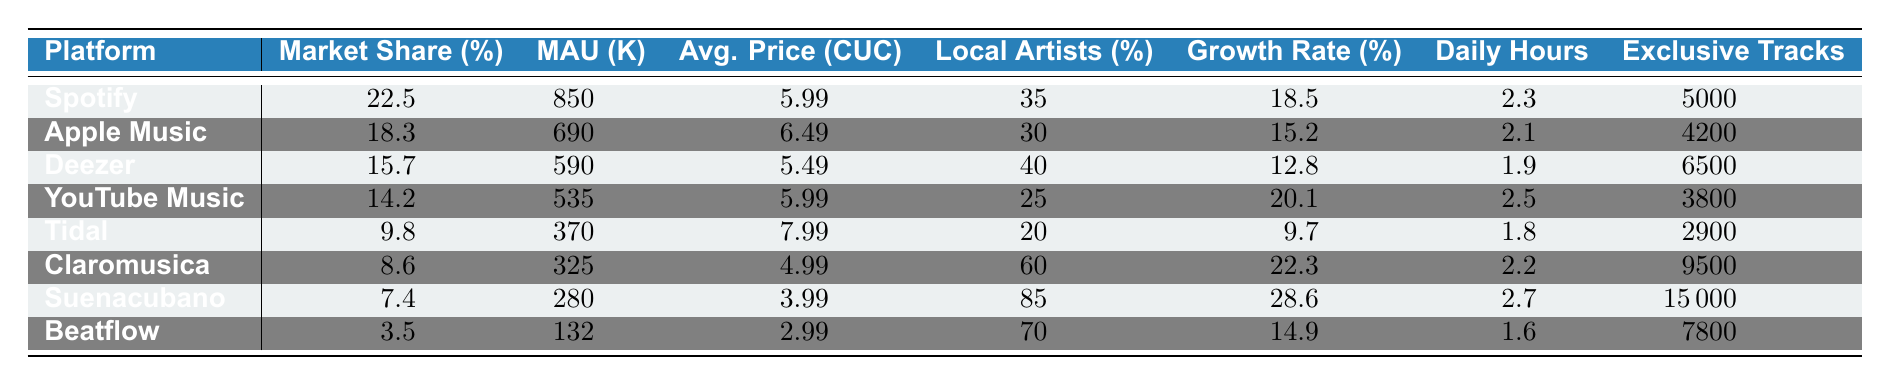What is the market share percentage of Spotify? The market share percentage for Spotify is directly listed in the table under the "Market Share (%)" column. For Spotify, the value is 22.5%.
Answer: 22.5% Which streaming platform has the highest number of monthly active users? The table lists the monthly active users for each platform. By comparing the values, Spotify has the highest number with 850,000 users.
Answer: Spotify What is the average subscription price of Apple Music? The average subscription price for Apple Music is indicated in the "Avg. Price (CUC)" column. For Apple Music, the value is 6.49 CUC.
Answer: 6.49 CUC Do more than 60% of local Cuban artists appear on Suenacubano? The percentage of local Cuban artists for Suenacubano is listed under the "Local Artists (%)" column. Suenacubano has a percentage of 85%, which is more than 60%.
Answer: Yes What is the total number of exclusive tracks offered by all platforms combined? To find the total number of exclusive tracks, sum the values in the "Exclusive Tracks" column: 5000 + 4200 + 6500 + 3800 + 2900 + 9500 + 15000 + 7800 =  43,700.
Answer: 43,700 Which platform has the highest average daily listening hours? The "Daily Hours" column shows the average daily listening hours for each platform. Suenacubano has the highest at 2.7 hours.
Answer: Suenacubano What is the difference in market share percentage between Deezer and YouTube Music? Deezer has a market share of 15.7% and YouTube Music has 14.2%. The difference is calculated as 15.7% - 14.2% = 1.5%.
Answer: 1.5% What is the average growth rate of streaming platforms based on the table? To find the average growth rate, sum all the growth rates from the "Growth Rate (%)" column and divide by the number of platforms: (18.5 + 15.2 + 12.8 + 20.1 + 9.7 + 22.3 + 28.6 + 14.9) / 8 = 17.2%.
Answer: 17.2% Which platform has the lowest average subscription price, and what is that price? By examining the "Avg. Price (CUC)" column, Beatflow has the lowest subscription price listed as 2.99 CUC.
Answer: Beatflow, 2.99 CUC If we consider only local platforms, which has the highest user growth rate? Looking at the "user growth rate yoY" column for only local platforms (Claromusica, Suenacubano, and Beatflow), Suenacubano has the highest growth rate at 28.6%.
Answer: Suenacubano 